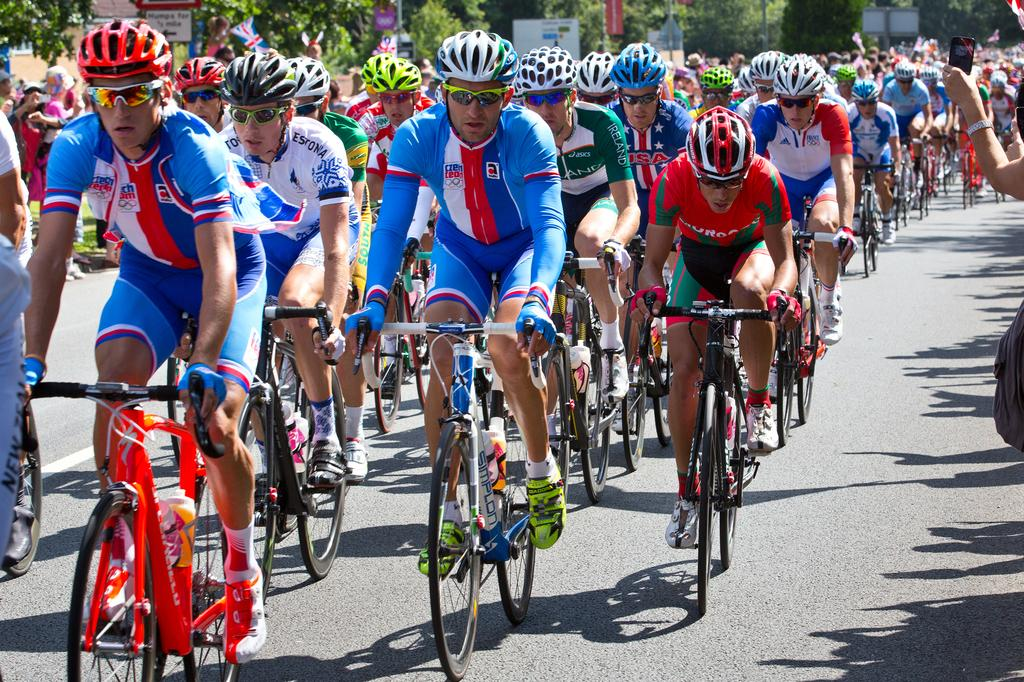What are the people in the image doing? The people in the image are riding bicycles. What can be seen behind the people riding bicycles? There are trees visible behind the people. What other objects or structures can be seen in the background of the image? There are boards and flags in the background of the image. Are there any other people visible in the image? Yes, there are people standing in the background of the image. Can you tell me what wish the person in the image is making? There is no person making a wish in the image; the people are riding bicycles. What type of ornament is hanging from the bicycles in the image? There are no ornaments hanging from the bicycles in the image; the people are simply riding them. 